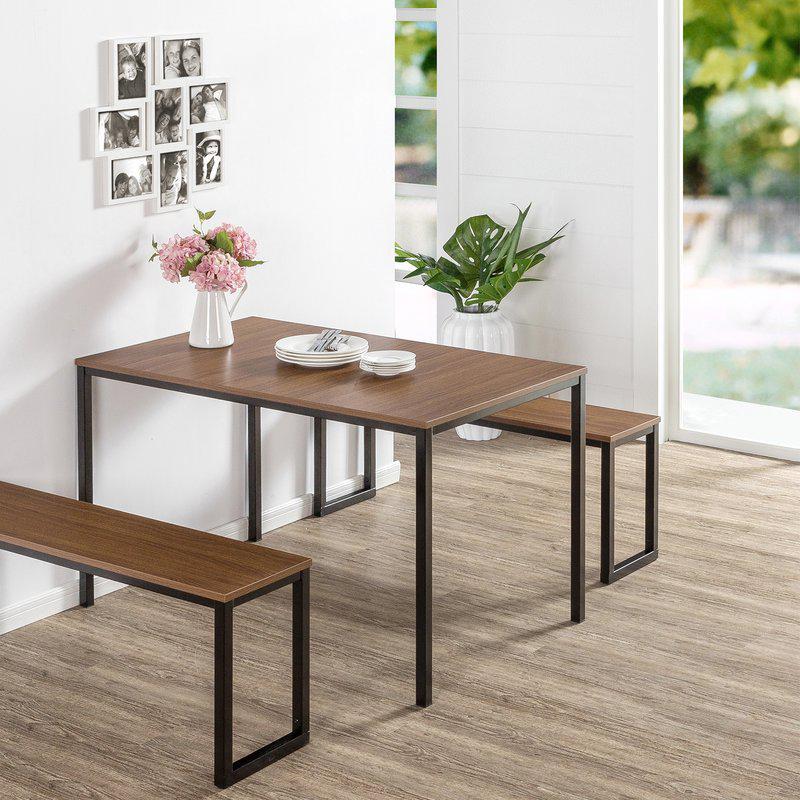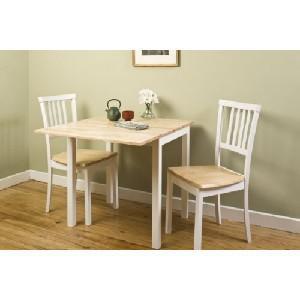The first image is the image on the left, the second image is the image on the right. Considering the images on both sides, is "The right image shows a small table white table with two chairs that sits flush to a wall and has a top that extends outward." valid? Answer yes or no. Yes. The first image is the image on the left, the second image is the image on the right. Given the left and right images, does the statement "One of the images shows a high top table with stools." hold true? Answer yes or no. No. 